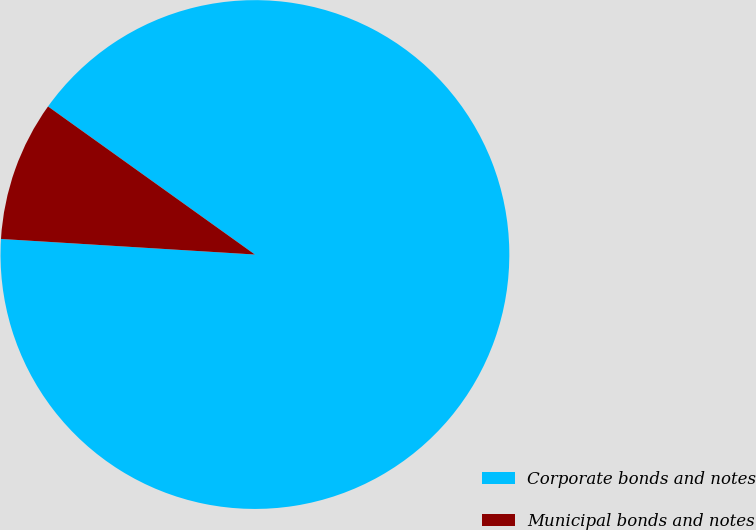Convert chart to OTSL. <chart><loc_0><loc_0><loc_500><loc_500><pie_chart><fcel>Corporate bonds and notes<fcel>Municipal bonds and notes<nl><fcel>91.09%<fcel>8.91%<nl></chart> 